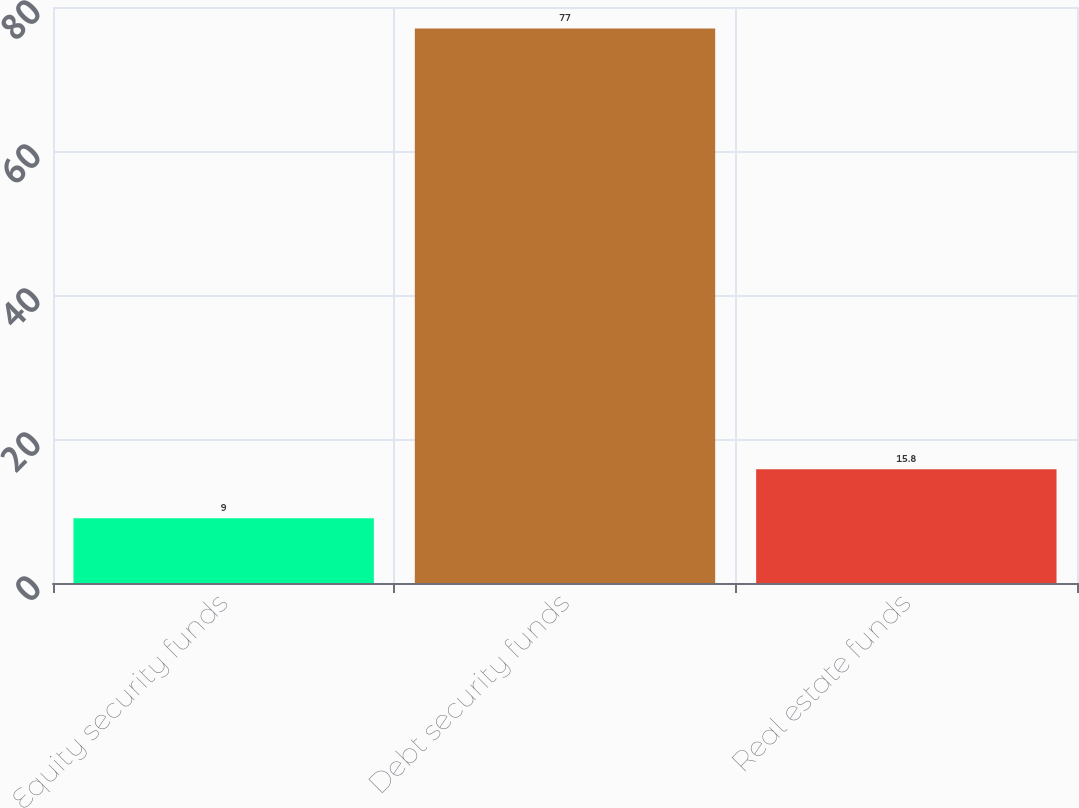Convert chart to OTSL. <chart><loc_0><loc_0><loc_500><loc_500><bar_chart><fcel>Equity security funds<fcel>Debt security funds<fcel>Real estate funds<nl><fcel>9<fcel>77<fcel>15.8<nl></chart> 